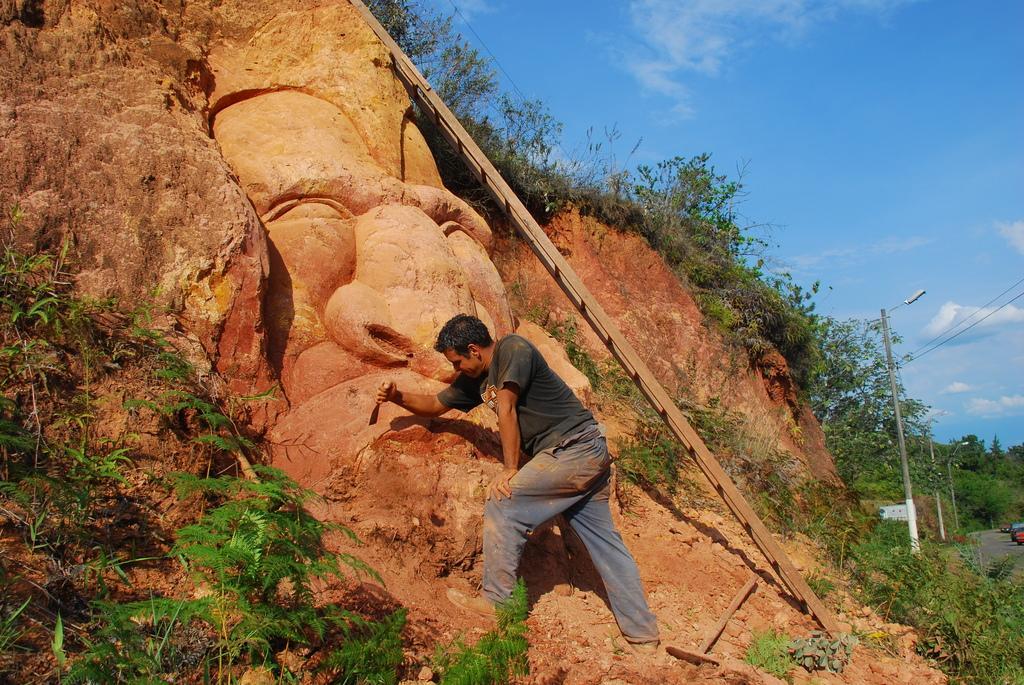Could you give a brief overview of what you see in this image? In this picture I can see a man in front and I see that he is holding a thing. I can also see few plants and I can see the rocks. In the background I can see few more plants, poles, wires, few trees and the clear sky. 